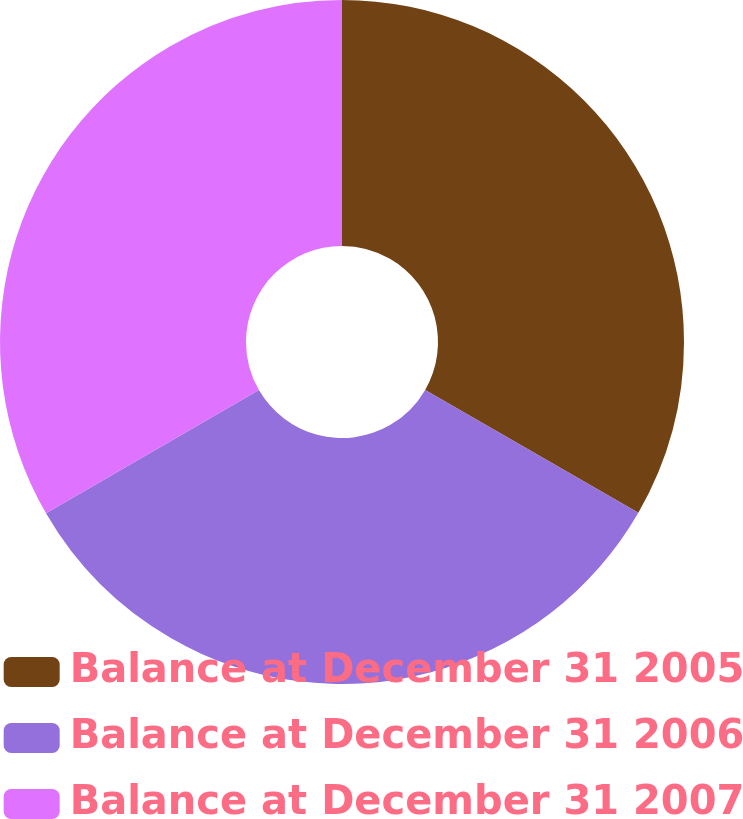Convert chart to OTSL. <chart><loc_0><loc_0><loc_500><loc_500><pie_chart><fcel>Balance at December 31 2005<fcel>Balance at December 31 2006<fcel>Balance at December 31 2007<nl><fcel>33.32%<fcel>33.33%<fcel>33.35%<nl></chart> 